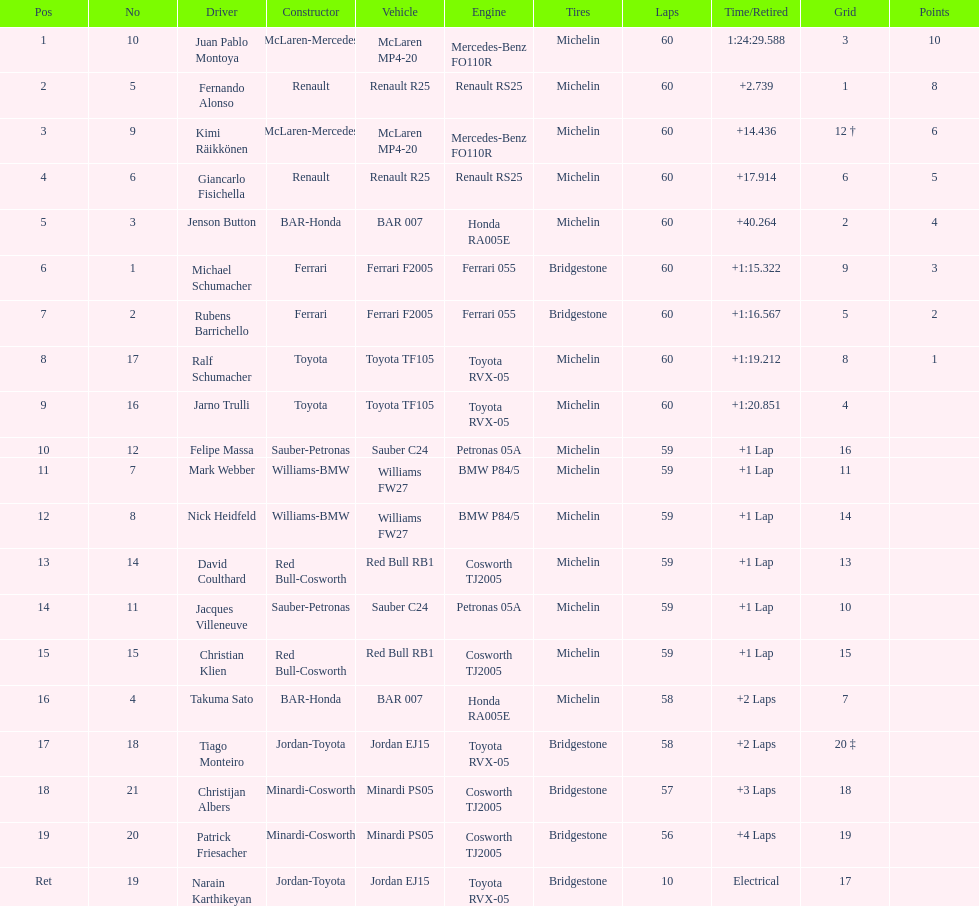How many drivers received points from the race? 8. 